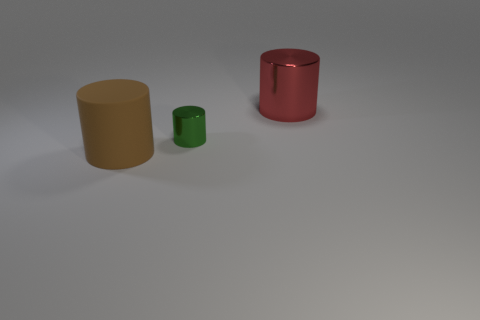How many gray things are either big shiny spheres or metallic cylinders?
Offer a very short reply. 0. There is another green object that is the same shape as the big rubber object; what is its material?
Your response must be concise. Metal. There is a metal object to the right of the tiny green cylinder; what is its shape?
Provide a short and direct response. Cylinder. Is there a big brown block made of the same material as the large brown object?
Offer a terse response. No. Does the brown object have the same size as the green shiny cylinder?
Provide a short and direct response. No. How many cylinders are either tiny green things or red things?
Give a very brief answer. 2. What number of other red objects have the same shape as the red metallic thing?
Your answer should be very brief. 0. Is the number of cylinders on the right side of the green cylinder greater than the number of rubber cylinders that are behind the red thing?
Keep it short and to the point. Yes. Does the large cylinder that is behind the tiny green cylinder have the same color as the tiny metal cylinder?
Offer a very short reply. No. The red thing has what size?
Offer a very short reply. Large. 